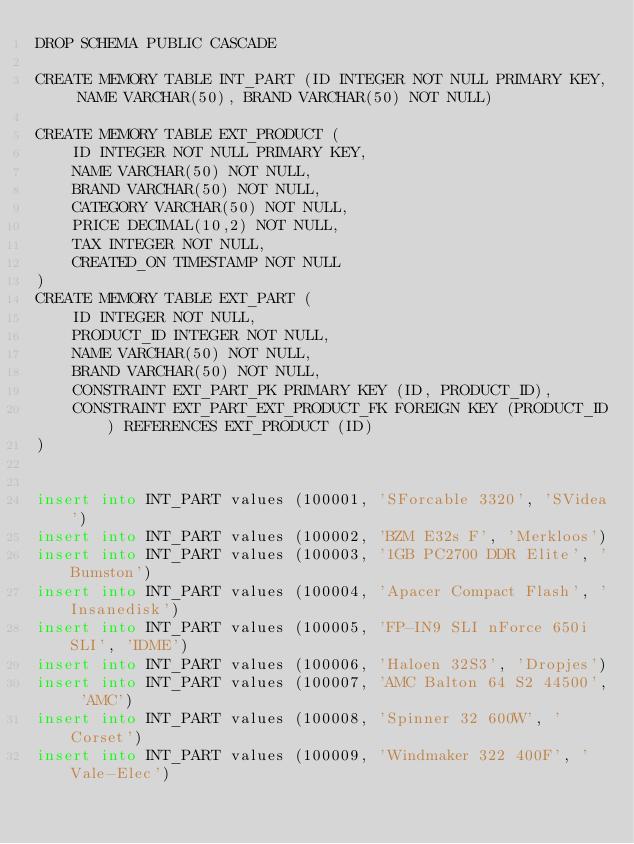Convert code to text. <code><loc_0><loc_0><loc_500><loc_500><_SQL_>DROP SCHEMA PUBLIC CASCADE

CREATE MEMORY TABLE INT_PART (ID INTEGER NOT NULL PRIMARY KEY, NAME VARCHAR(50), BRAND VARCHAR(50) NOT NULL)

CREATE MEMORY TABLE EXT_PRODUCT (
    ID INTEGER NOT NULL PRIMARY KEY,
    NAME VARCHAR(50) NOT NULL,
    BRAND VARCHAR(50) NOT NULL,
    CATEGORY VARCHAR(50) NOT NULL,
    PRICE DECIMAL(10,2) NOT NULL,
    TAX INTEGER NOT NULL,
    CREATED_ON TIMESTAMP NOT NULL
)
CREATE MEMORY TABLE EXT_PART (
    ID INTEGER NOT NULL,
    PRODUCT_ID INTEGER NOT NULL,
    NAME VARCHAR(50) NOT NULL,
    BRAND VARCHAR(50) NOT NULL,
    CONSTRAINT EXT_PART_PK PRIMARY KEY (ID, PRODUCT_ID),
    CONSTRAINT EXT_PART_EXT_PRODUCT_FK FOREIGN KEY (PRODUCT_ID) REFERENCES EXT_PRODUCT (ID)
)


insert into INT_PART values (100001, 'SForcable 3320', 'SVidea')
insert into INT_PART values (100002, 'BZM E32s F', 'Merkloos')
insert into INT_PART values (100003, '1GB PC2700 DDR Elite', 'Bumston')
insert into INT_PART values (100004, 'Apacer Compact Flash', 'Insanedisk')
insert into INT_PART values (100005, 'FP-IN9 SLI nForce 650i SLI', 'IDME')
insert into INT_PART values (100006, 'Haloen 32S3', 'Dropjes')
insert into INT_PART values (100007, 'AMC Balton 64 S2 44500', 'AMC')
insert into INT_PART values (100008, 'Spinner 32 600W', 'Corset')
insert into INT_PART values (100009, 'Windmaker 322 400F', 'Vale-Elec')
</code> 